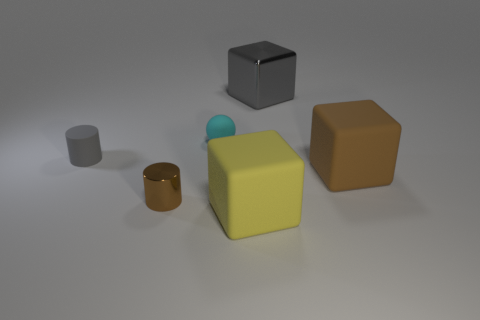Add 2 small rubber spheres. How many objects exist? 8 Subtract all spheres. How many objects are left? 5 Add 5 tiny shiny cylinders. How many tiny shiny cylinders are left? 6 Add 1 tiny cylinders. How many tiny cylinders exist? 3 Subtract 0 yellow spheres. How many objects are left? 6 Subtract all brown blocks. Subtract all small cyan objects. How many objects are left? 4 